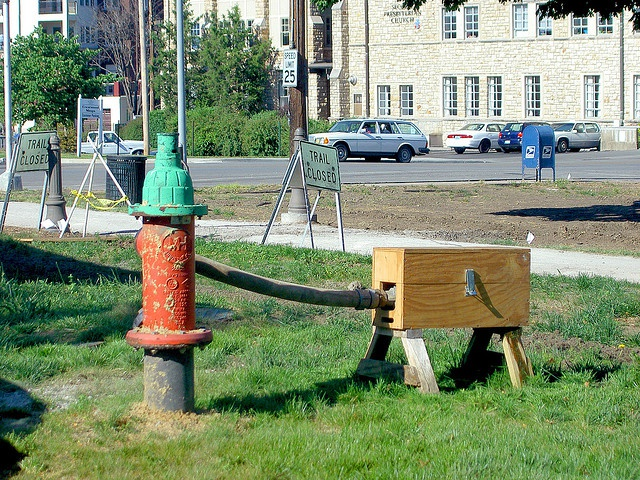Describe the objects in this image and their specific colors. I can see fire hydrant in gray, black, salmon, maroon, and darkgray tones, car in gray, black, white, and lightblue tones, car in gray, white, black, lightblue, and darkgray tones, car in gray, darkgray, white, and black tones, and truck in gray, white, lightblue, blue, and darkgray tones in this image. 